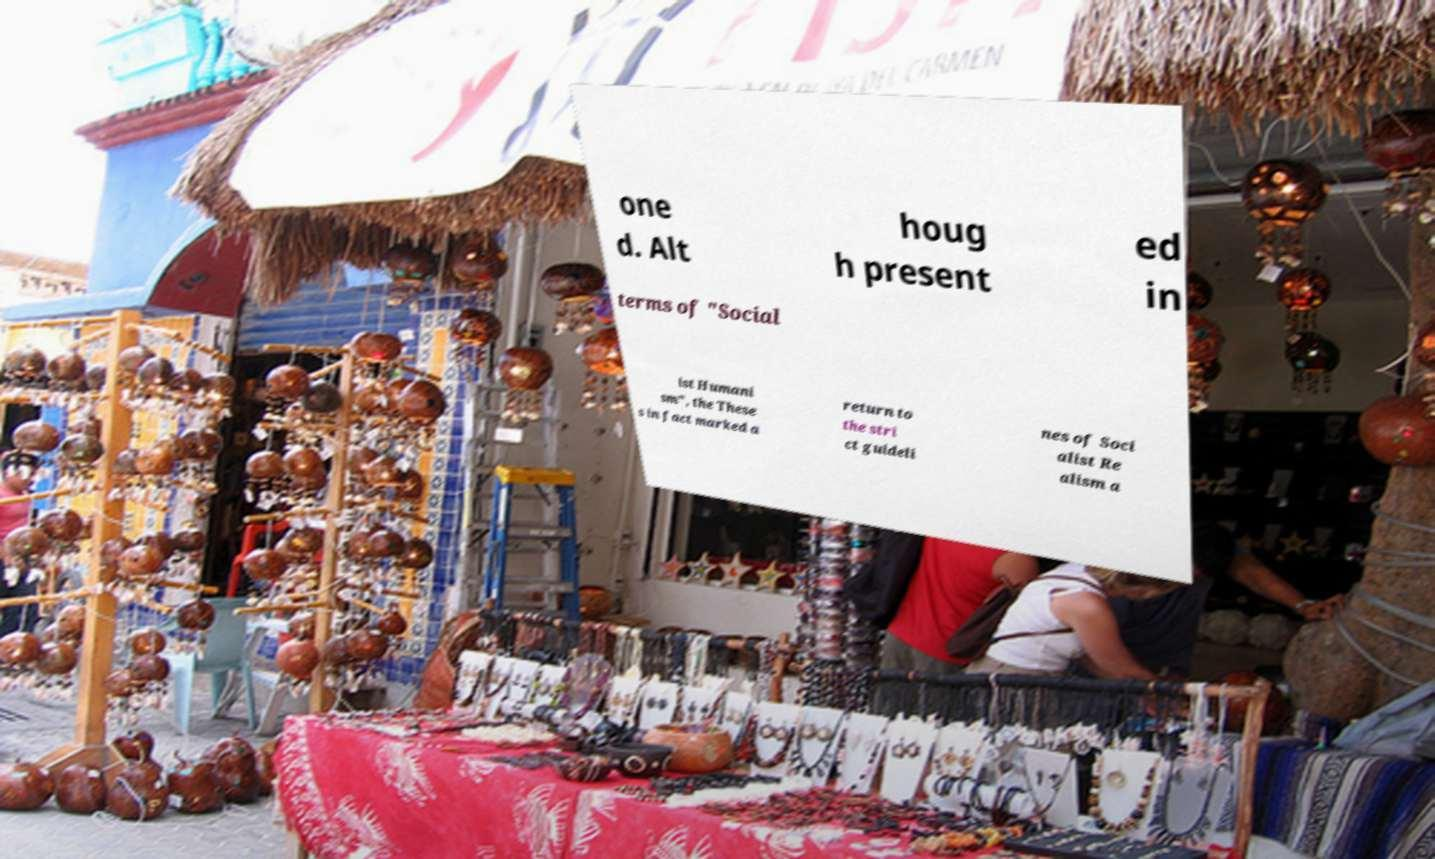Please identify and transcribe the text found in this image. one d. Alt houg h present ed in terms of "Social ist Humani sm", the These s in fact marked a return to the stri ct guideli nes of Soci alist Re alism a 